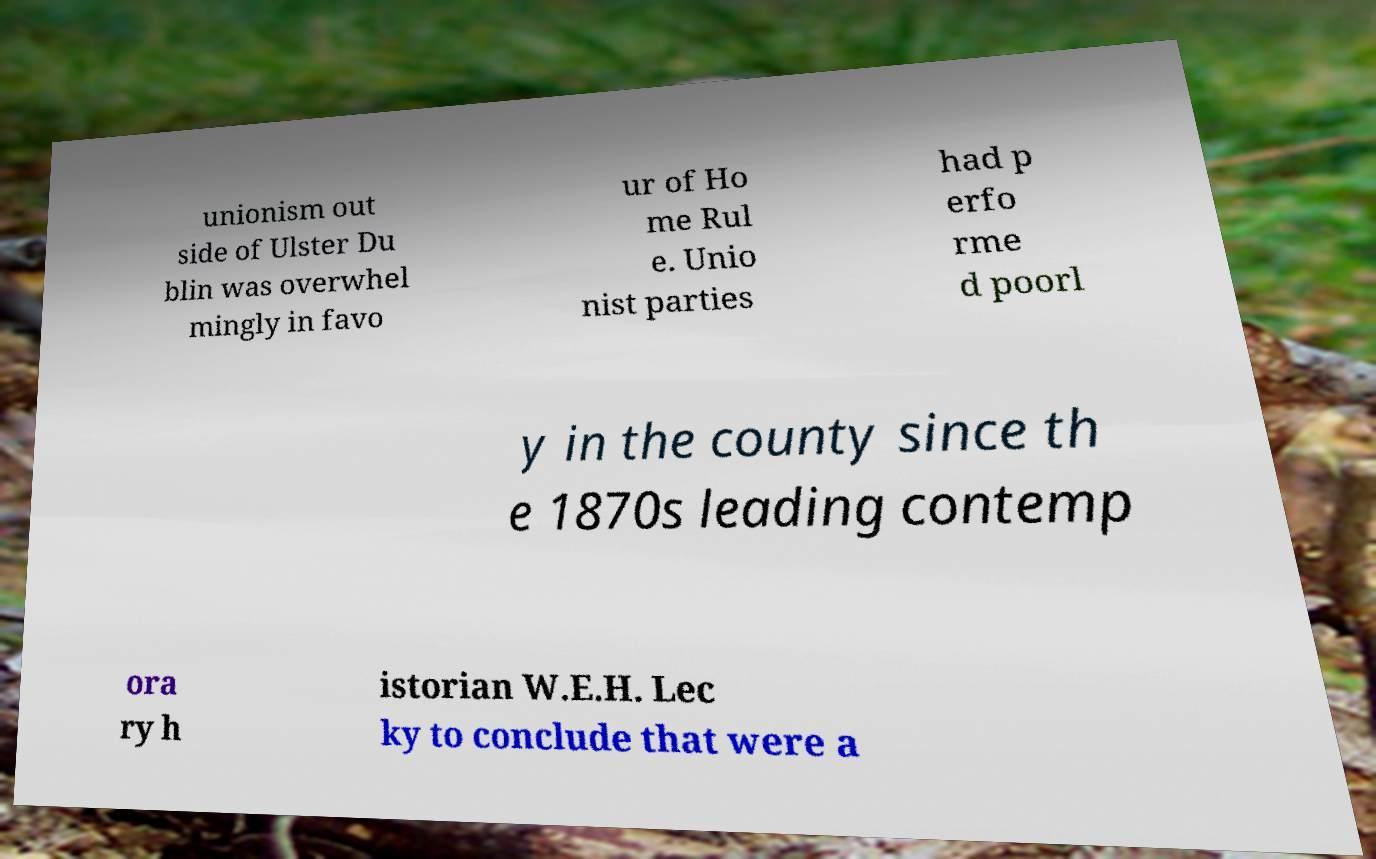Please read and relay the text visible in this image. What does it say? unionism out side of Ulster Du blin was overwhel mingly in favo ur of Ho me Rul e. Unio nist parties had p erfo rme d poorl y in the county since th e 1870s leading contemp ora ry h istorian W.E.H. Lec ky to conclude that were a 